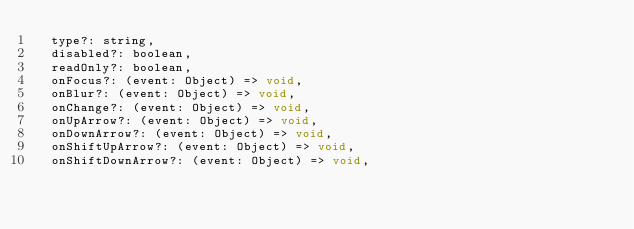Convert code to text. <code><loc_0><loc_0><loc_500><loc_500><_JavaScript_>  type?: string,
  disabled?: boolean,
  readOnly?: boolean,
  onFocus?: (event: Object) => void,
  onBlur?: (event: Object) => void,
  onChange?: (event: Object) => void,
  onUpArrow?: (event: Object) => void,
  onDownArrow?: (event: Object) => void,
  onShiftUpArrow?: (event: Object) => void,
  onShiftDownArrow?: (event: Object) => void,</code> 